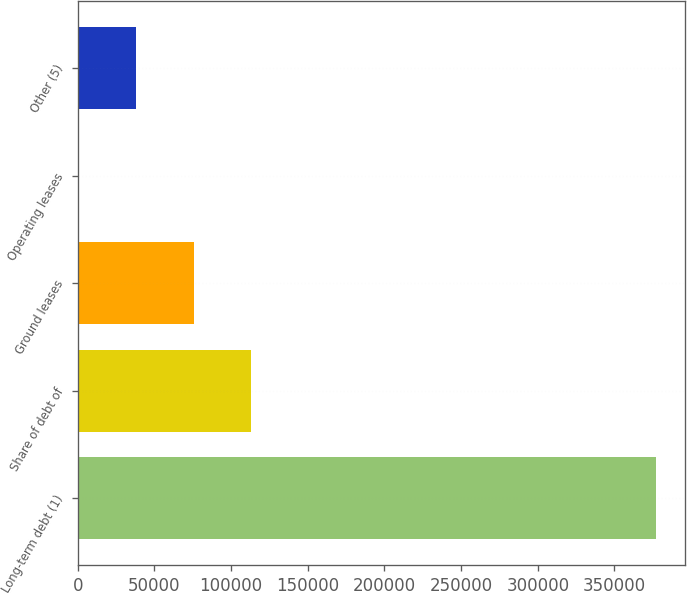<chart> <loc_0><loc_0><loc_500><loc_500><bar_chart><fcel>Long-term debt (1)<fcel>Share of debt of<fcel>Ground leases<fcel>Operating leases<fcel>Other (5)<nl><fcel>377120<fcel>113235<fcel>75537.6<fcel>142<fcel>37839.8<nl></chart> 